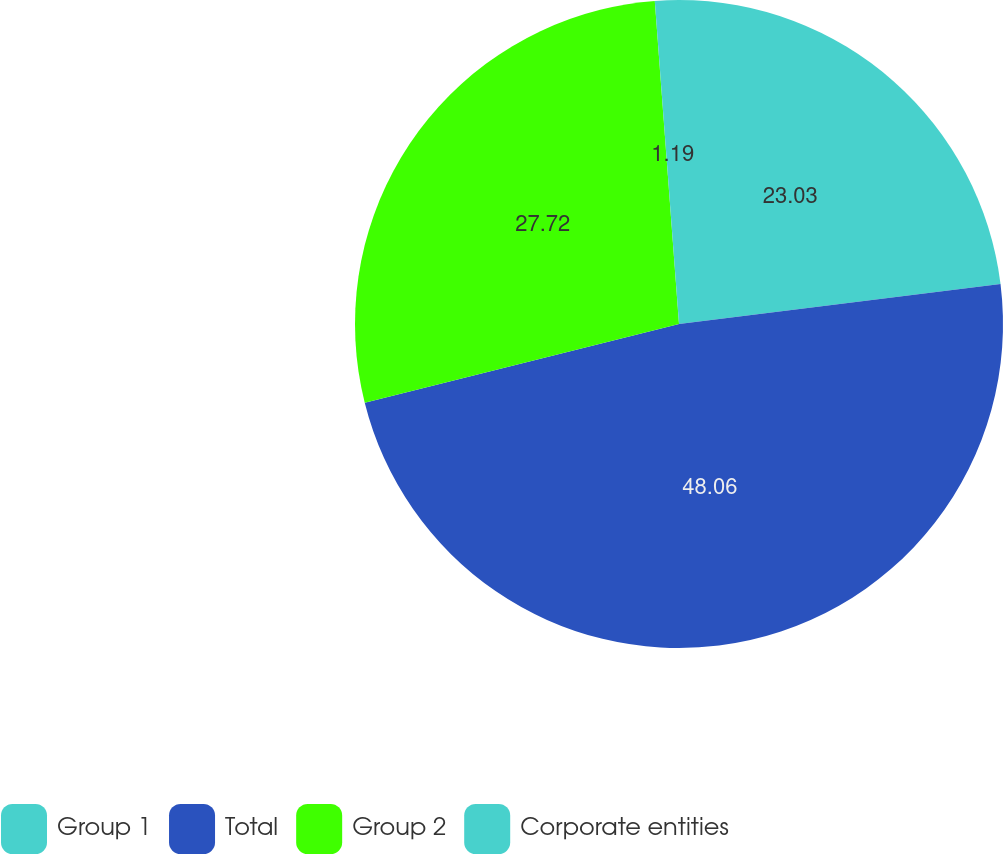<chart> <loc_0><loc_0><loc_500><loc_500><pie_chart><fcel>Group 1<fcel>Total<fcel>Group 2<fcel>Corporate entities<nl><fcel>23.03%<fcel>48.06%<fcel>27.72%<fcel>1.19%<nl></chart> 